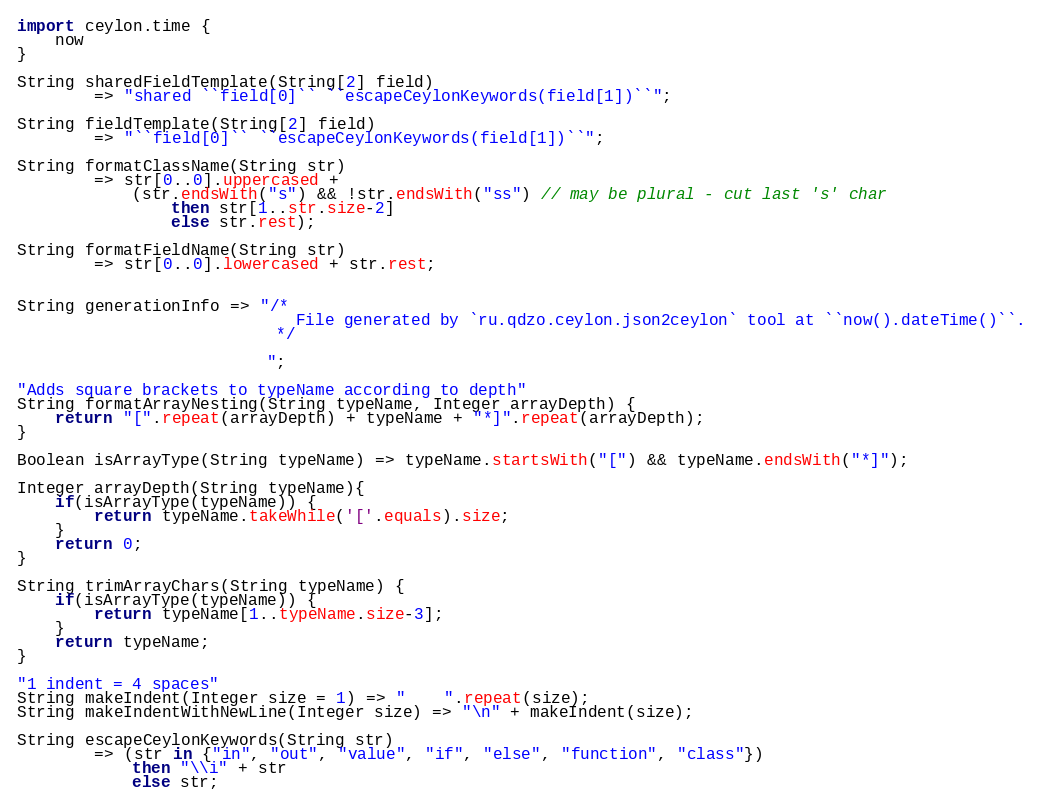Convert code to text. <code><loc_0><loc_0><loc_500><loc_500><_Ceylon_>import ceylon.time {
    now
}

String sharedFieldTemplate(String[2] field)
        => "shared ``field[0]`` ``escapeCeylonKeywords(field[1])``";

String fieldTemplate(String[2] field)
        => "``field[0]`` ``escapeCeylonKeywords(field[1])``";

String formatClassName(String str)
        => str[0..0].uppercased +
            (str.endsWith("s") && !str.endsWith("ss") // may be plural - cut last 's' char
                then str[1..str.size-2]
                else str.rest);

String formatFieldName(String str)
        => str[0..0].lowercased + str.rest;


String generationInfo => "/*
                             File generated by `ru.qdzo.ceylon.json2ceylon` tool at ``now().dateTime()``.
                           */

                          ";

"Adds square brackets to typeName according to depth"
String formatArrayNesting(String typeName, Integer arrayDepth) {
    return "[".repeat(arrayDepth) + typeName + "*]".repeat(arrayDepth);
}

Boolean isArrayType(String typeName) => typeName.startsWith("[") && typeName.endsWith("*]");

Integer arrayDepth(String typeName){
    if(isArrayType(typeName)) {
        return typeName.takeWhile('['.equals).size;
    }
    return 0;
}

String trimArrayChars(String typeName) {
    if(isArrayType(typeName)) {
        return typeName[1..typeName.size-3];
    }
    return typeName;
}

"1 indent = 4 spaces"
String makeIndent(Integer size = 1) => "    ".repeat(size);
String makeIndentWithNewLine(Integer size) => "\n" + makeIndent(size);

String escapeCeylonKeywords(String str)
        => (str in {"in", "out", "value", "if", "else", "function", "class"})
            then "\\i" + str
            else str;
</code> 